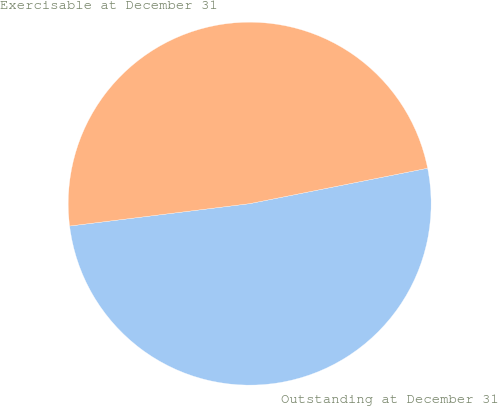Convert chart. <chart><loc_0><loc_0><loc_500><loc_500><pie_chart><fcel>Outstanding at December 31<fcel>Exercisable at December 31<nl><fcel>51.16%<fcel>48.84%<nl></chart> 